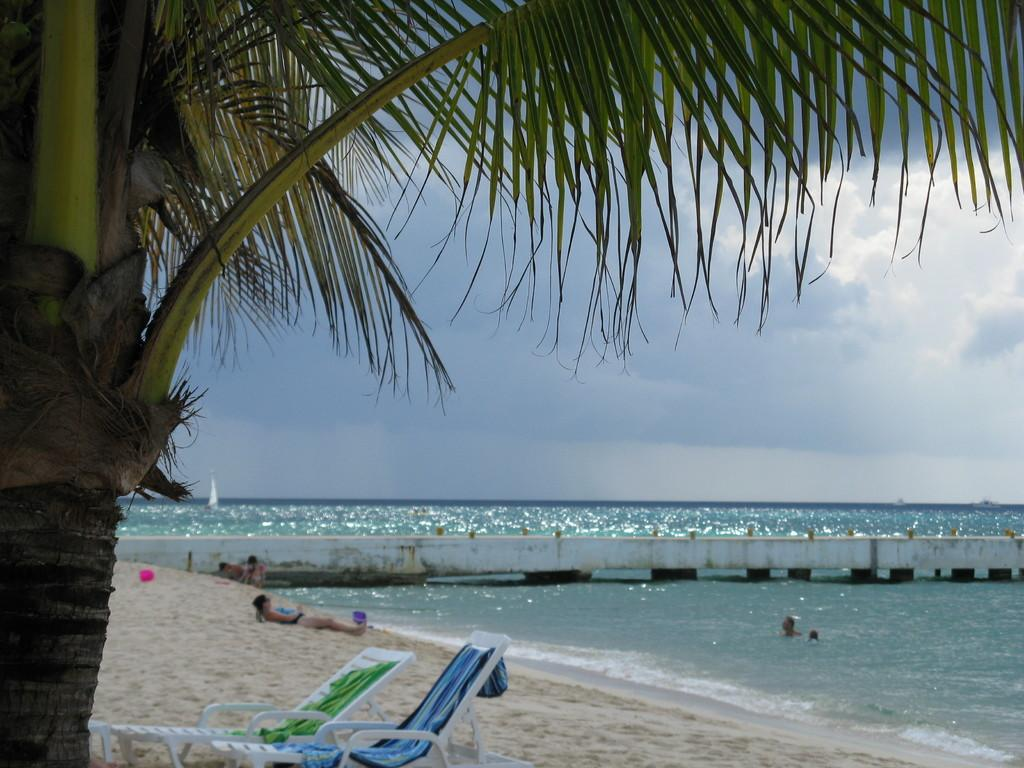What type of location is depicted in the image? There is a beach in the image. What is the person in the image doing? A person is lying on the sand in front of the beach. What type of plant can be seen in the image? There is a coconut tree in the image. How many chairs are under the coconut tree? There are two chairs under the coconut tree. What type of apparel is the person wearing during the rainstorm in the image? There is no rainstorm present in the image, and no apparel can be seen on the person lying on the sand. 